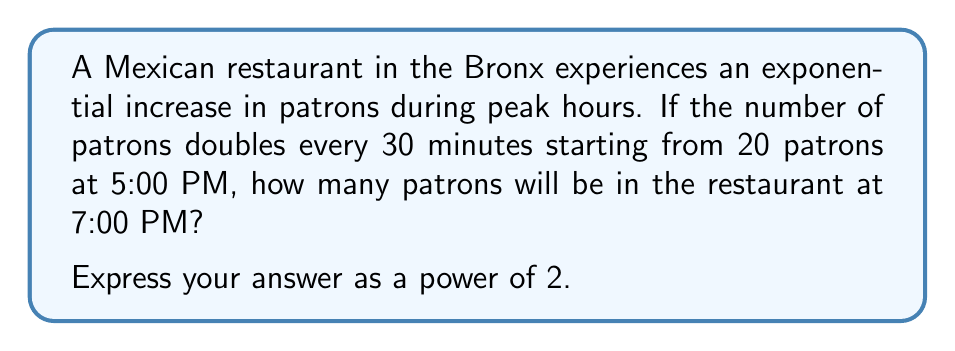Show me your answer to this math problem. Let's approach this step-by-step:

1) First, we need to determine how many 30-minute intervals occur between 5:00 PM and 7:00 PM.
   From 5:00 PM to 7:00 PM, there are 2 hours, which is equivalent to 4 30-minute intervals.

2) We're told that the number of patrons doubles every 30 minutes. This means we're dealing with exponential growth with a base of 2.

3) The initial number of patrons at 5:00 PM is 20.

4) We can express this mathematically as:
   $$ \text{Number of patrons} = 20 \cdot 2^n $$
   Where $n$ is the number of 30-minute intervals.

5) We determined in step 1 that there are 4 intervals, so $n = 4$.

6) Plugging this into our equation:
   $$ \text{Number of patrons} = 20 \cdot 2^4 $$

7) Simplify:
   $$ \text{Number of patrons} = 20 \cdot 16 = 320 $$

8) To express this as a power of 2, we can factor 320:
   $$ 320 = 20 \cdot 16 = (2^2 \cdot 5) \cdot 2^4 = 2^6 \cdot 5 $$

Therefore, the number of patrons at 7:00 PM can be expressed as $2^6 \cdot 5$.
Answer: $2^6 \cdot 5$ 